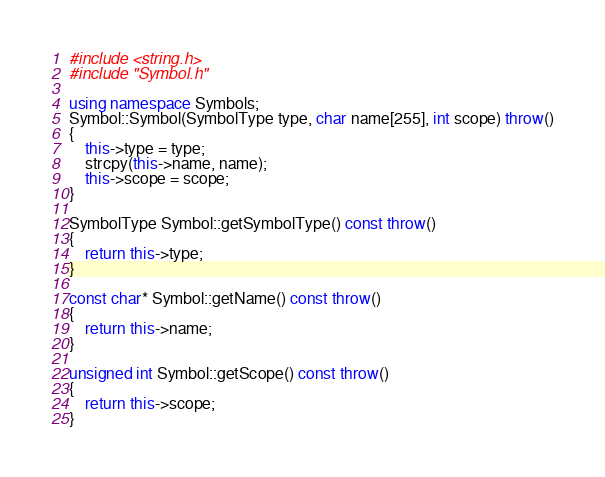Convert code to text. <code><loc_0><loc_0><loc_500><loc_500><_C++_>#include <string.h>
#include "Symbol.h"

using namespace Symbols;
Symbol::Symbol(SymbolType type, char name[255], int scope) throw()
{
    this->type = type;
    strcpy(this->name, name);
    this->scope = scope;
}

SymbolType Symbol::getSymbolType() const throw()
{
    return this->type;
}

const char* Symbol::getName() const throw()
{
    return this->name;
}

unsigned int Symbol::getScope() const throw()
{
    return this->scope;
}
</code> 